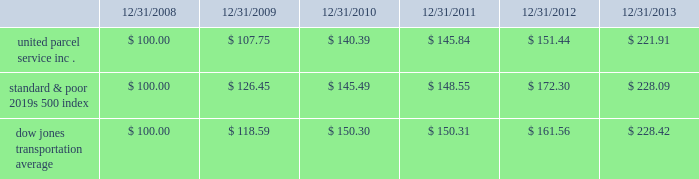Shareowner return performance graph the following performance graph and related information shall not be deemed 201csoliciting material 201d or to be 201cfiled 201d with the sec , nor shall such information be incorporated by reference into any future filing under the securities act of 1933 or securities exchange act of 1934 , each as amended , except to the extent that the company specifically incorporates such information by reference into such filing .
The following graph shows a five year comparison of cumulative total shareowners 2019 returns for our class b common stock , the standard & poor 2019s 500 index , and the dow jones transportation average .
The comparison of the total cumulative return on investment , which is the change in the quarterly stock price plus reinvested dividends for each of the quarterly periods , assumes that $ 100 was invested on december 31 , 2008 in the standard & poor 2019s 500 index , the dow jones transportation average , and our class b common stock. .

What was the percentage total cumulative return on investment for united parcel service inc . for the five years ended 12/31/2013? 
Computations: ((221.91 - 100) / 100)
Answer: 1.2191. 